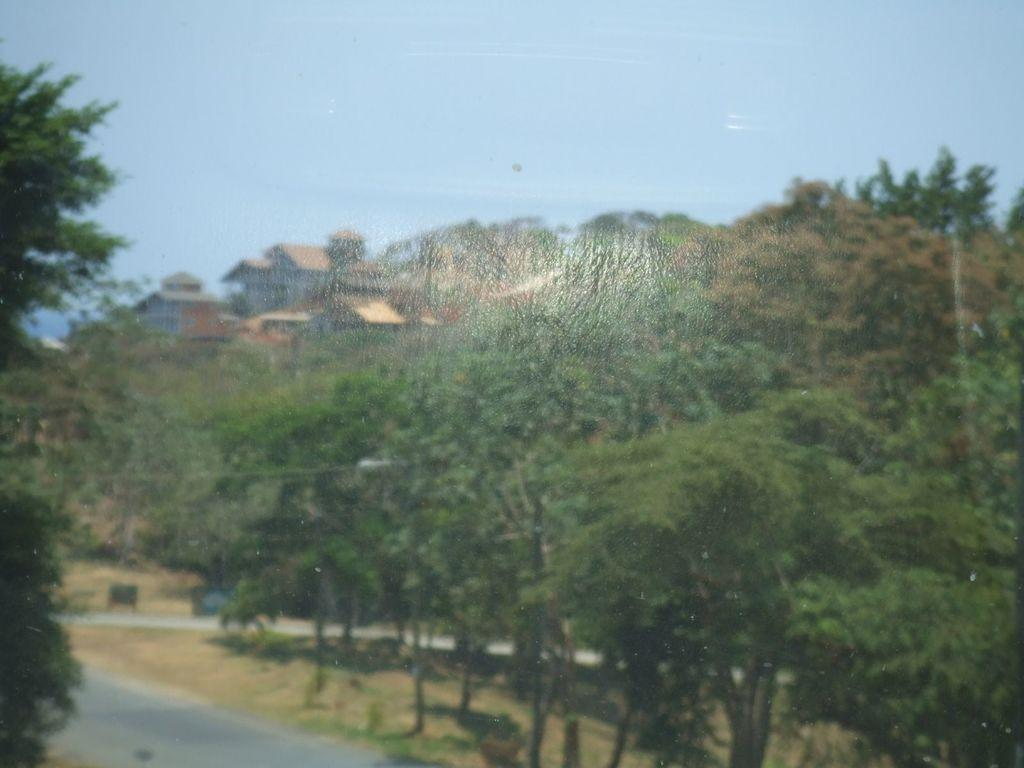What type of vegetation can be seen in the image? There are trees with branches and leaves in the image. What type of structures are present in the image? There are houses in the image. What is visible in the background of the image? The sky is visible in the image. What type of pathway can be seen in the image? There is a road in the image. What type of stone is the ladybug sitting on in the image? There is no ladybug or stone present in the image. What color is the copper roof on the house in the image? There is no copper roof mentioned in the image; the houses are not described in detail. 